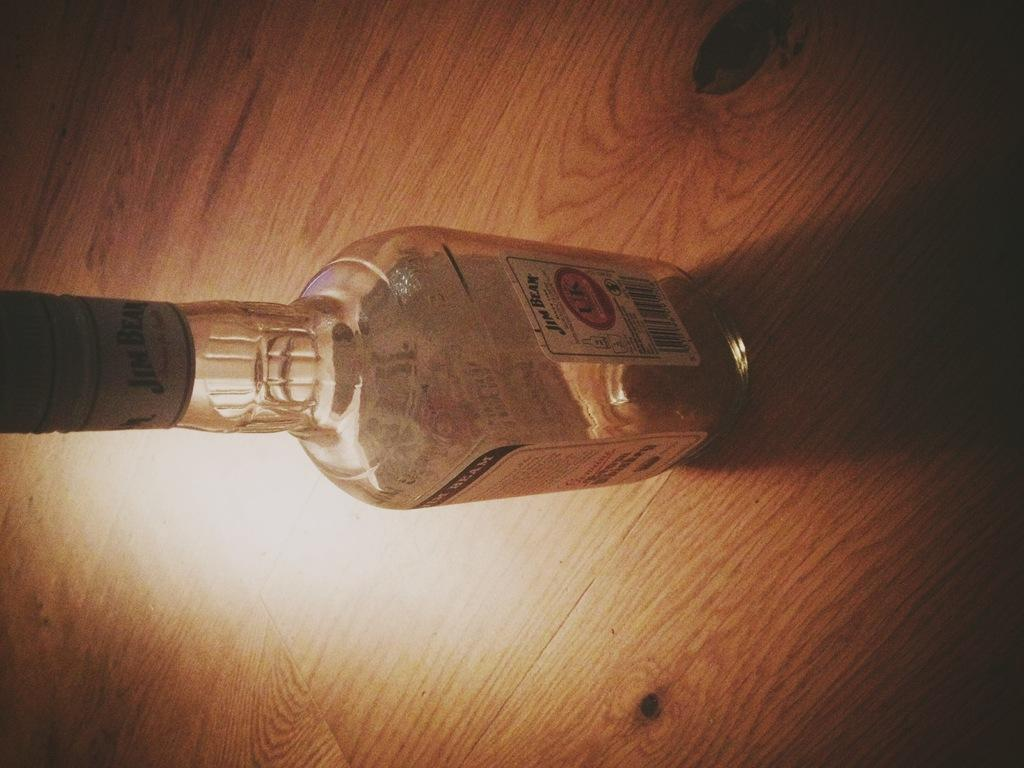What object is visible in the image that is made of glass? There is a glass bottle in the image. What is on the glass bottle? The glass bottle has a sticker on it. Where is the glass bottle located in the image? The glass bottle is placed on a brown table. How does the earth contribute to the contents of the glass bottle in the image? The earth does not contribute to the contents of the glass bottle in the image; it is not mentioned or depicted in the image. 